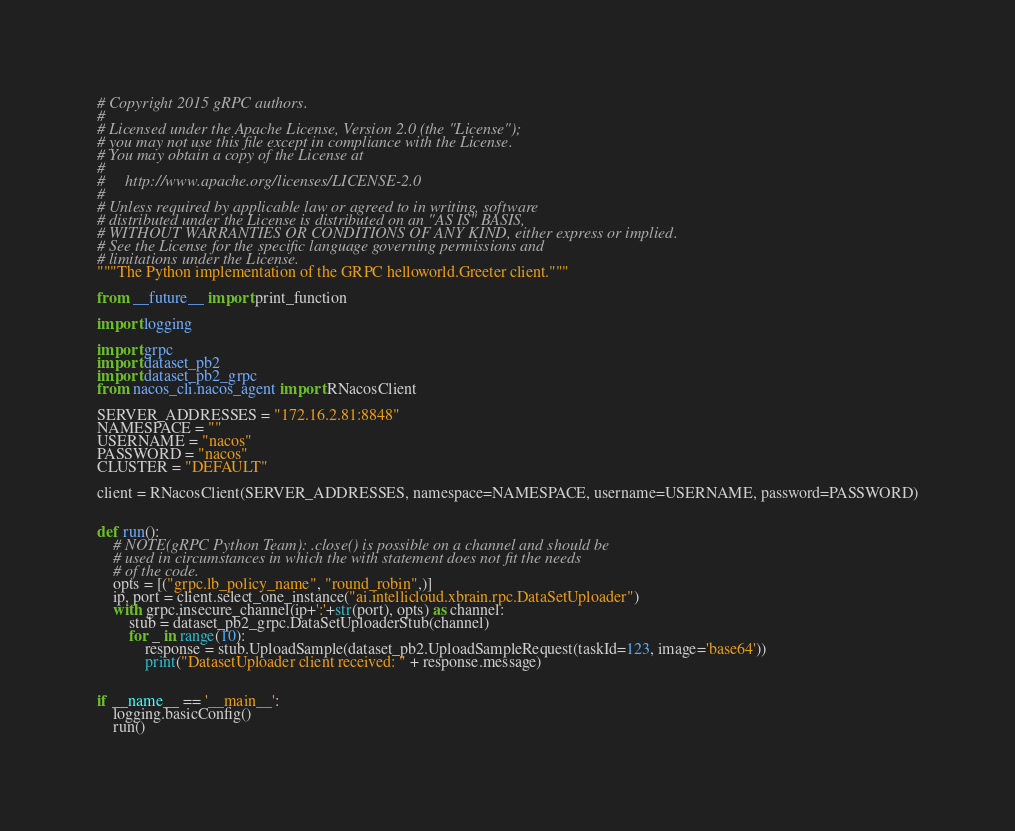<code> <loc_0><loc_0><loc_500><loc_500><_Python_># Copyright 2015 gRPC authors.
#
# Licensed under the Apache License, Version 2.0 (the "License");
# you may not use this file except in compliance with the License.
# You may obtain a copy of the License at
#
#     http://www.apache.org/licenses/LICENSE-2.0
#
# Unless required by applicable law or agreed to in writing, software
# distributed under the License is distributed on an "AS IS" BASIS,
# WITHOUT WARRANTIES OR CONDITIONS OF ANY KIND, either express or implied.
# See the License for the specific language governing permissions and
# limitations under the License.
"""The Python implementation of the GRPC helloworld.Greeter client."""

from __future__ import print_function

import logging

import grpc
import dataset_pb2
import dataset_pb2_grpc
from nacos_cli.nacos_agent import RNacosClient

SERVER_ADDRESSES = "172.16.2.81:8848"
NAMESPACE = ""
USERNAME = "nacos"
PASSWORD = "nacos"
CLUSTER = "DEFAULT"

client = RNacosClient(SERVER_ADDRESSES, namespace=NAMESPACE, username=USERNAME, password=PASSWORD)


def run():
    # NOTE(gRPC Python Team): .close() is possible on a channel and should be
    # used in circumstances in which the with statement does not fit the needs
    # of the code.
    opts = [("grpc.lb_policy_name", "round_robin",)]
    ip, port = client.select_one_instance("ai.intellicloud.xbrain.rpc.DataSetUploader")
    with grpc.insecure_channel(ip+':'+str(port), opts) as channel:
        stub = dataset_pb2_grpc.DataSetUploaderStub(channel)
        for _ in range(10):
            response = stub.UploadSample(dataset_pb2.UploadSampleRequest(taskId=123, image='base64'))
            print("DatasetUploader client received: " + response.message)


if __name__ == '__main__':
    logging.basicConfig()
    run()
</code> 